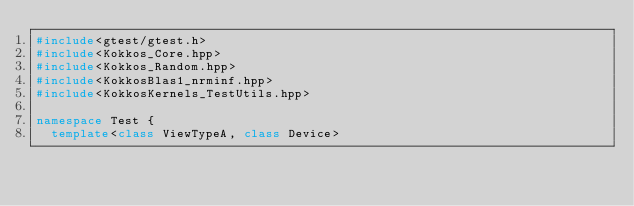Convert code to text. <code><loc_0><loc_0><loc_500><loc_500><_C++_>#include<gtest/gtest.h>
#include<Kokkos_Core.hpp>
#include<Kokkos_Random.hpp>
#include<KokkosBlas1_nrminf.hpp>
#include<KokkosKernels_TestUtils.hpp>

namespace Test {
  template<class ViewTypeA, class Device></code> 